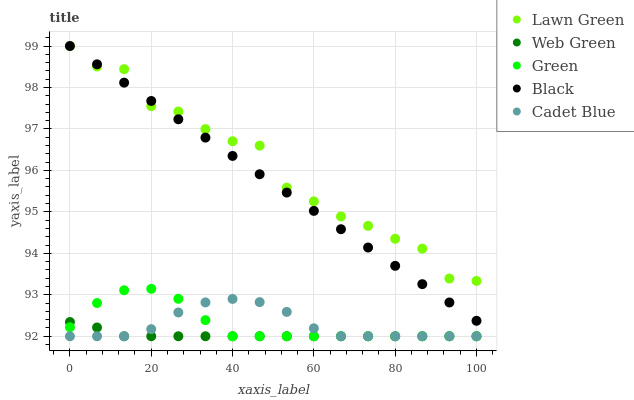Does Web Green have the minimum area under the curve?
Answer yes or no. Yes. Does Lawn Green have the maximum area under the curve?
Answer yes or no. Yes. Does Cadet Blue have the minimum area under the curve?
Answer yes or no. No. Does Cadet Blue have the maximum area under the curve?
Answer yes or no. No. Is Black the smoothest?
Answer yes or no. Yes. Is Lawn Green the roughest?
Answer yes or no. Yes. Is Cadet Blue the smoothest?
Answer yes or no. No. Is Cadet Blue the roughest?
Answer yes or no. No. Does Cadet Blue have the lowest value?
Answer yes or no. Yes. Does Black have the lowest value?
Answer yes or no. No. Does Black have the highest value?
Answer yes or no. Yes. Does Cadet Blue have the highest value?
Answer yes or no. No. Is Green less than Lawn Green?
Answer yes or no. Yes. Is Lawn Green greater than Green?
Answer yes or no. Yes. Does Cadet Blue intersect Green?
Answer yes or no. Yes. Is Cadet Blue less than Green?
Answer yes or no. No. Is Cadet Blue greater than Green?
Answer yes or no. No. Does Green intersect Lawn Green?
Answer yes or no. No. 